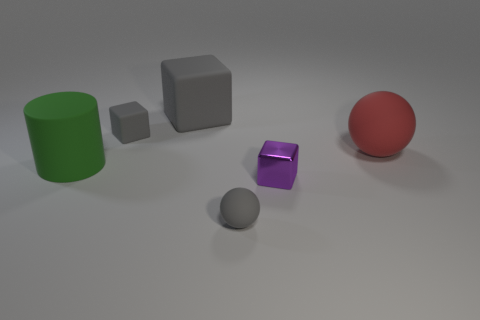Are there any other things that are made of the same material as the small purple object?
Provide a short and direct response. No. Is the shape of the large matte object on the right side of the large matte cube the same as the small object behind the small purple thing?
Provide a succinct answer. No. What number of things are either small gray cubes or gray matte spheres?
Provide a succinct answer. 2. What material is the object in front of the purple thing that is on the left side of the red matte sphere?
Provide a short and direct response. Rubber. Is there a matte thing of the same color as the small metal block?
Give a very brief answer. No. There is a rubber cube that is the same size as the green rubber cylinder; what is its color?
Offer a terse response. Gray. There is a gray block that is left of the large matte thing behind the small rubber object behind the purple thing; what is it made of?
Ensure brevity in your answer.  Rubber. Is the color of the large sphere the same as the matte sphere that is in front of the large matte cylinder?
Provide a short and direct response. No. What number of things are either gray rubber objects in front of the big green cylinder or big rubber objects that are right of the small rubber sphere?
Your answer should be compact. 2. What is the shape of the small gray rubber object behind the gray ball in front of the small purple block?
Provide a succinct answer. Cube. 